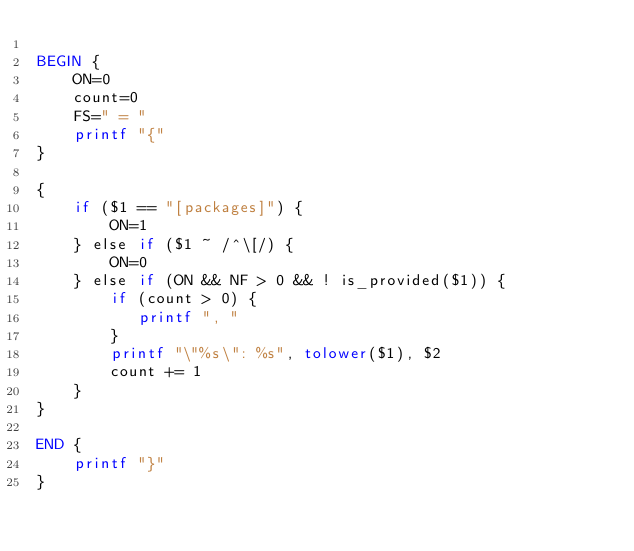<code> <loc_0><loc_0><loc_500><loc_500><_Awk_>
BEGIN {
    ON=0
    count=0
    FS=" = "
    printf "{"
}

{
    if ($1 == "[packages]") {
        ON=1
    } else if ($1 ~ /^\[/) {
        ON=0
    } else if (ON && NF > 0 && ! is_provided($1)) {
        if (count > 0) {
           printf ", "
        }
        printf "\"%s\": %s", tolower($1), $2
        count += 1
    }
}

END {
    printf "}"
}
</code> 